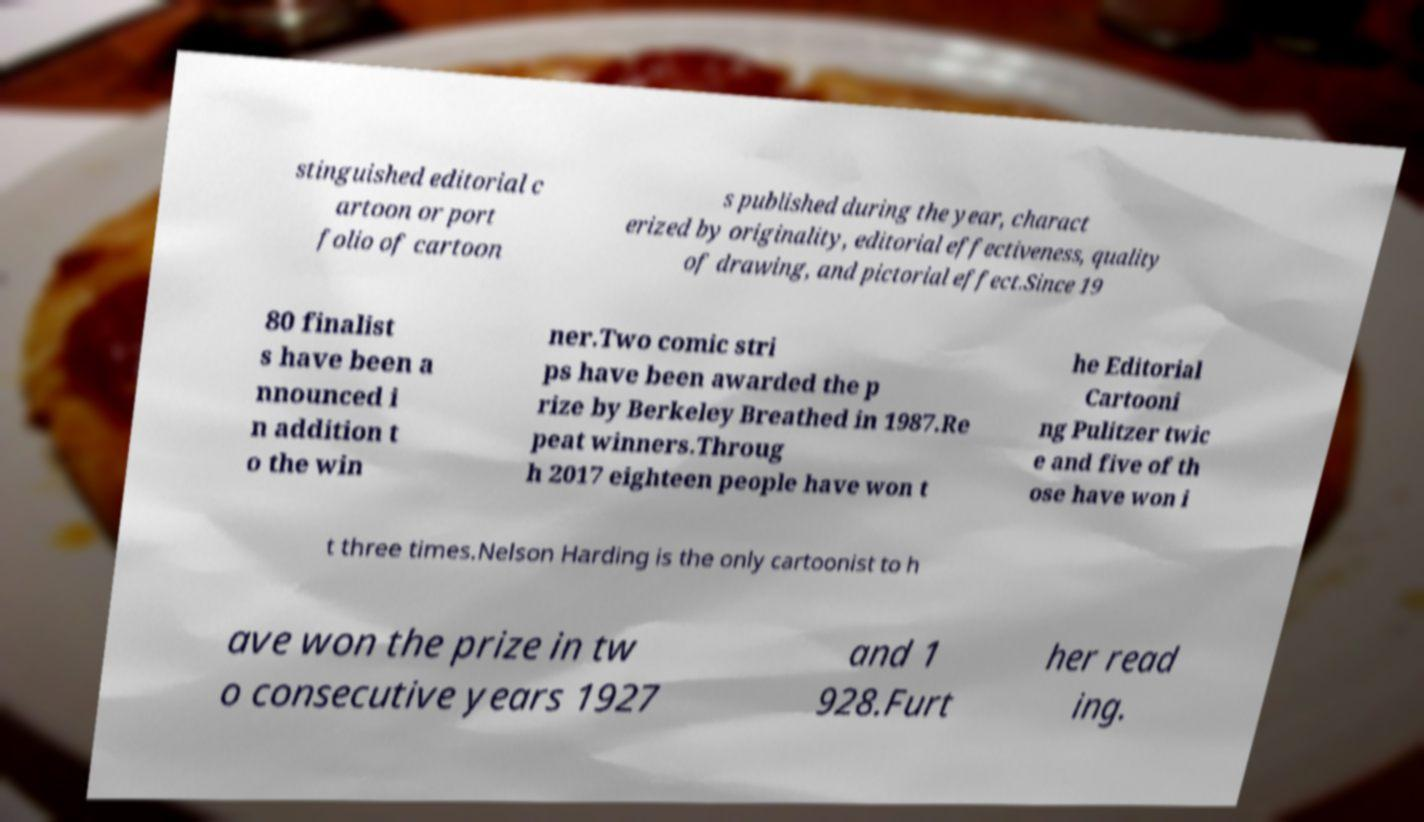Please read and relay the text visible in this image. What does it say? stinguished editorial c artoon or port folio of cartoon s published during the year, charact erized by originality, editorial effectiveness, quality of drawing, and pictorial effect.Since 19 80 finalist s have been a nnounced i n addition t o the win ner.Two comic stri ps have been awarded the p rize by Berkeley Breathed in 1987.Re peat winners.Throug h 2017 eighteen people have won t he Editorial Cartooni ng Pulitzer twic e and five of th ose have won i t three times.Nelson Harding is the only cartoonist to h ave won the prize in tw o consecutive years 1927 and 1 928.Furt her read ing. 